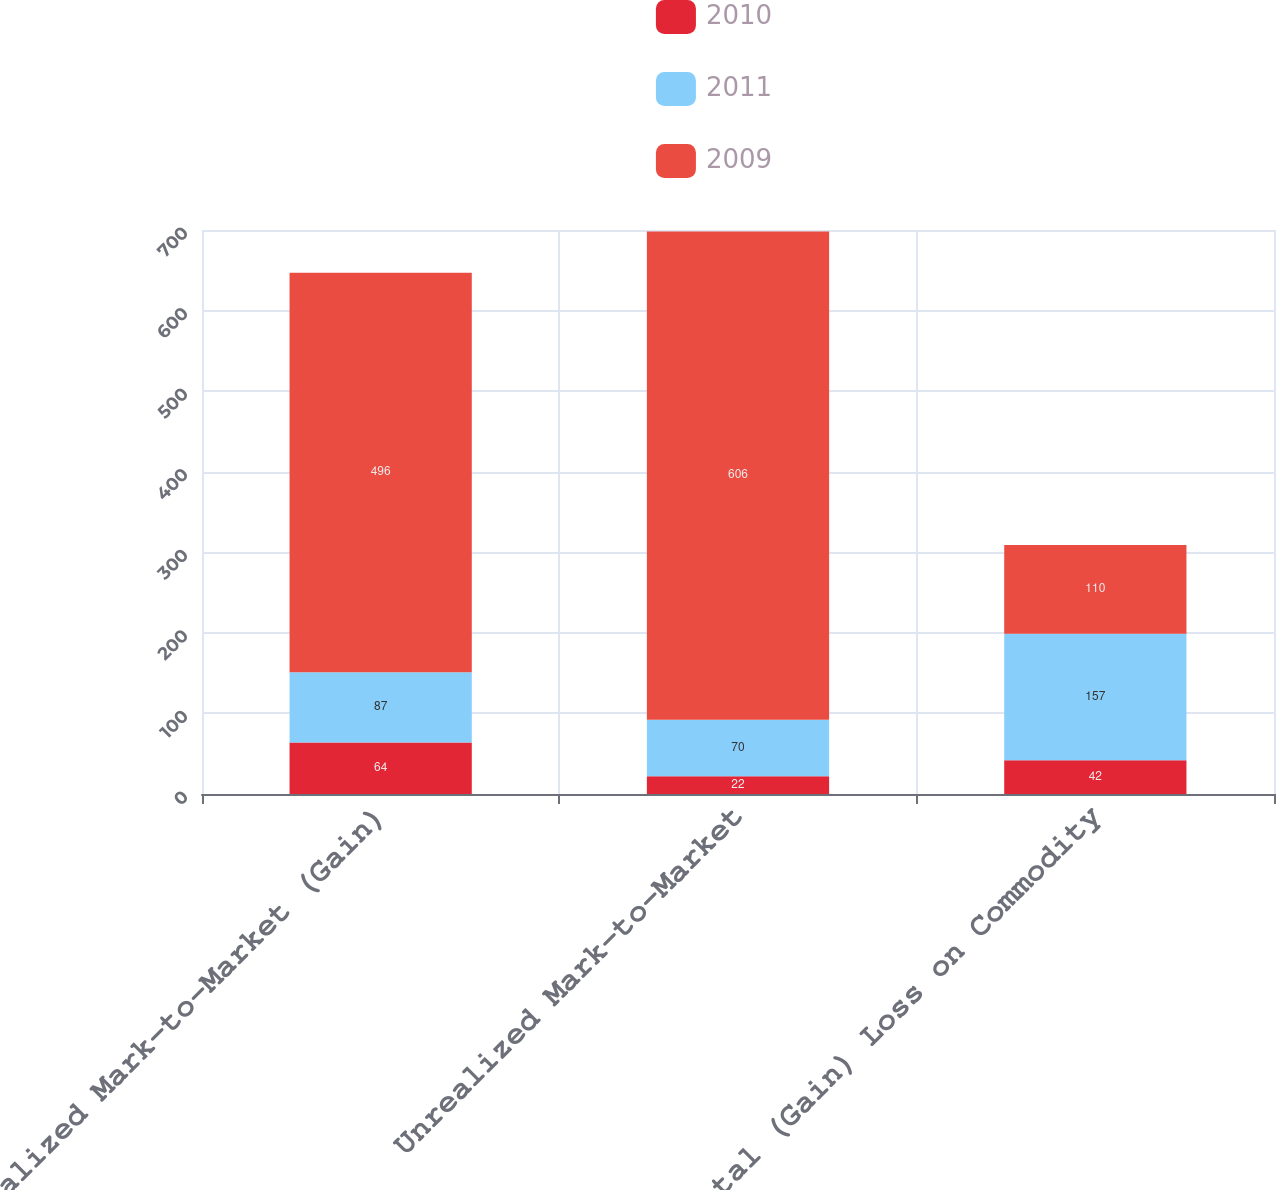Convert chart. <chart><loc_0><loc_0><loc_500><loc_500><stacked_bar_chart><ecel><fcel>Realized Mark-to-Market (Gain)<fcel>Unrealized Mark-to-Market<fcel>Total (Gain) Loss on Commodity<nl><fcel>2010<fcel>64<fcel>22<fcel>42<nl><fcel>2011<fcel>87<fcel>70<fcel>157<nl><fcel>2009<fcel>496<fcel>606<fcel>110<nl></chart> 